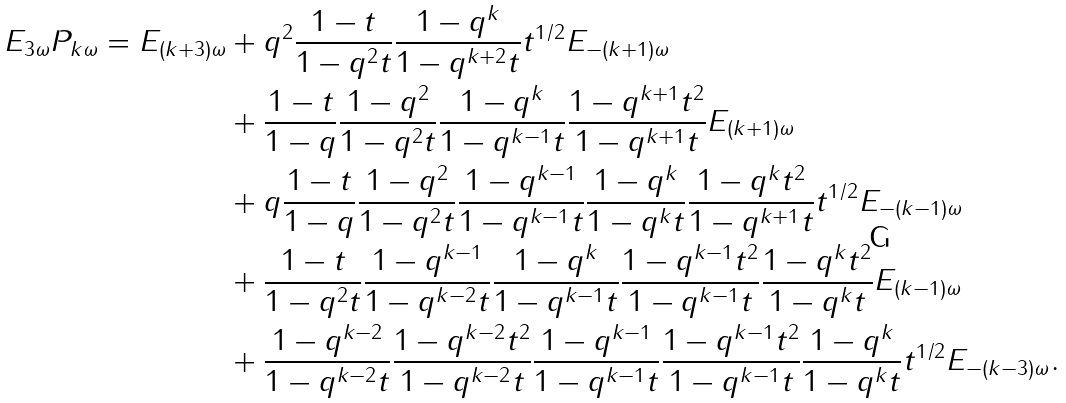<formula> <loc_0><loc_0><loc_500><loc_500>E _ { 3 \omega } P _ { k \omega } = E _ { ( k + 3 ) \omega } & + q ^ { 2 } \frac { 1 - t } { 1 - q ^ { 2 } t } \frac { 1 - q ^ { k } } { 1 - q ^ { k + 2 } t } t ^ { 1 / 2 } E _ { - ( k + 1 ) \omega } \\ & + \frac { 1 - t } { 1 - q } \frac { 1 - q ^ { 2 } } { 1 - q ^ { 2 } t } \frac { 1 - q ^ { k } } { 1 - q ^ { k - 1 } t } \frac { 1 - q ^ { k + 1 } t ^ { 2 } } { 1 - q ^ { k + 1 } t } E _ { ( k + 1 ) \omega } \\ & + q \frac { 1 - t } { 1 - q } \frac { 1 - q ^ { 2 } } { 1 - q ^ { 2 } t } \frac { 1 - q ^ { k - 1 } } { 1 - q ^ { k - 1 } t } \frac { 1 - q ^ { k } } { 1 - q ^ { k } t } \frac { 1 - q ^ { k } t ^ { 2 } } { 1 - q ^ { k + 1 } t } t ^ { 1 / 2 } E _ { - ( k - 1 ) \omega } \\ & + \frac { 1 - t } { 1 - q ^ { 2 } t } \frac { 1 - q ^ { k - 1 } } { 1 - q ^ { k - 2 } t } \frac { 1 - q ^ { k } } { 1 - q ^ { k - 1 } t } \frac { 1 - q ^ { k - 1 } t ^ { 2 } } { 1 - q ^ { k - 1 } t } \frac { 1 - q ^ { k } t ^ { 2 } } { 1 - q ^ { k } t } E _ { ( k - 1 ) \omega } \\ & + \frac { 1 - q ^ { k - 2 } } { 1 - q ^ { k - 2 } t } \frac { 1 - q ^ { k - 2 } t ^ { 2 } } { 1 - q ^ { k - 2 } t } \frac { 1 - q ^ { k - 1 } } { 1 - q ^ { k - 1 } t } \frac { 1 - q ^ { k - 1 } t ^ { 2 } } { 1 - q ^ { k - 1 } t } \frac { 1 - q ^ { k } } { 1 - q ^ { k } t } t ^ { 1 / 2 } E _ { - ( k - 3 ) \omega } .</formula> 